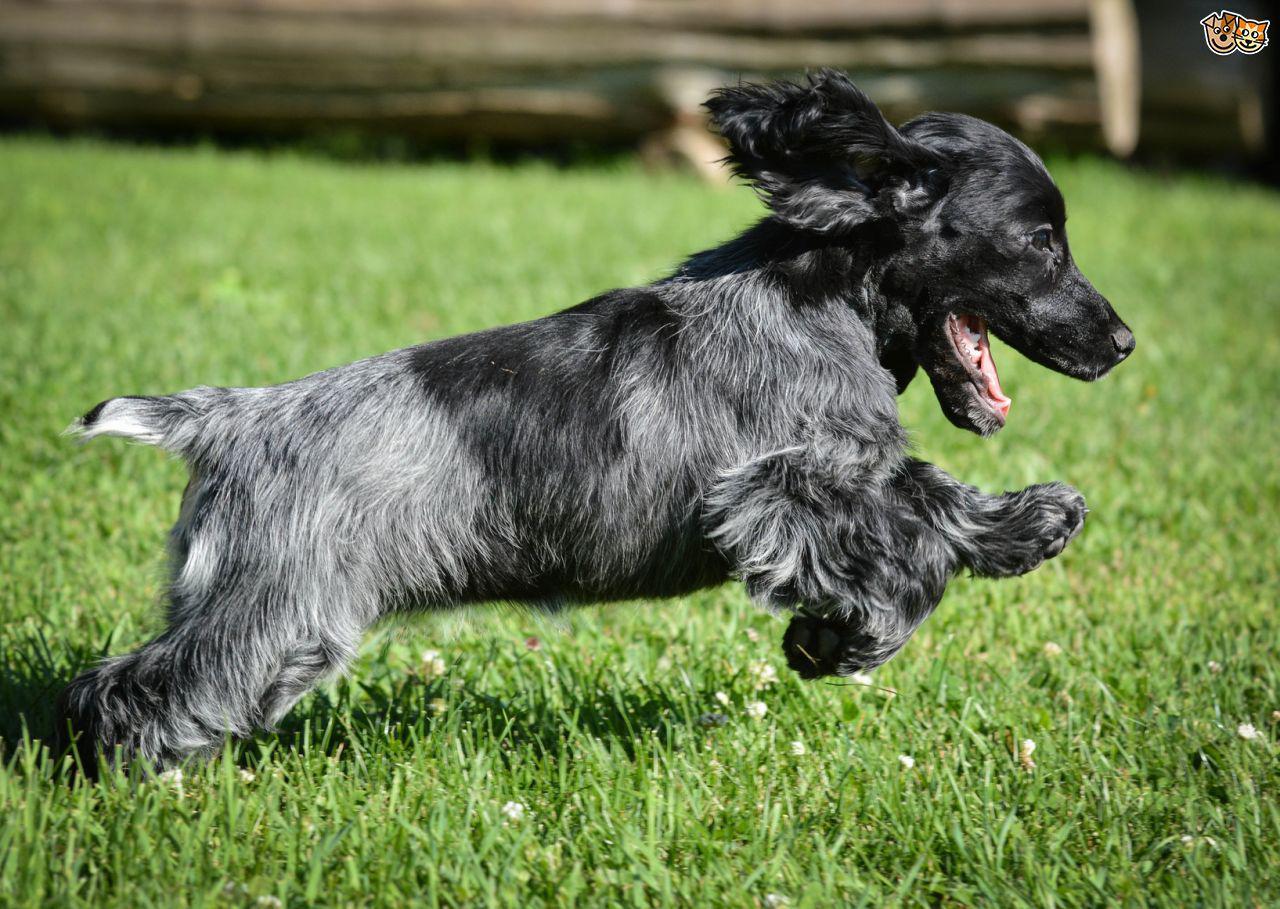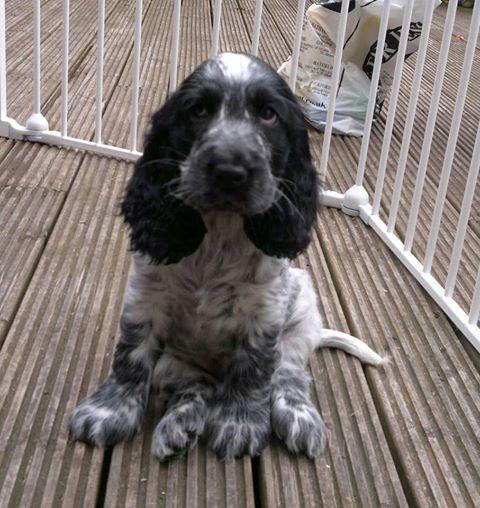The first image is the image on the left, the second image is the image on the right. Given the left and right images, does the statement "One image shows a black-and-gray spaniel sitting upright, and the other image shows a brown spaniel holding a game bird in its mouth." hold true? Answer yes or no. No. The first image is the image on the left, the second image is the image on the right. Evaluate the accuracy of this statement regarding the images: "An image contains a dog with a dead bird in its mouth.". Is it true? Answer yes or no. No. 